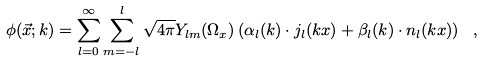Convert formula to latex. <formula><loc_0><loc_0><loc_500><loc_500>\phi ( \vec { x } ; k ) = \sum _ { l = 0 } ^ { \infty } \sum _ { m = - l } ^ { l } \sqrt { 4 \pi } Y _ { l m } ( \Omega _ { x } ) \left ( \alpha _ { l } ( k ) \cdot j _ { l } ( k x ) + \beta _ { l } ( k ) \cdot n _ { l } ( k x ) \right ) \ ,</formula> 